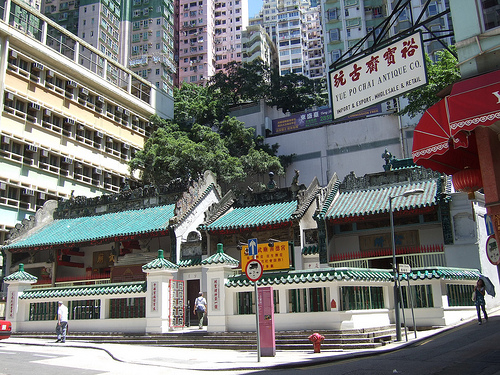<image>
Is there a building behind the board? Yes. From this viewpoint, the building is positioned behind the board, with the board partially or fully occluding the building. 